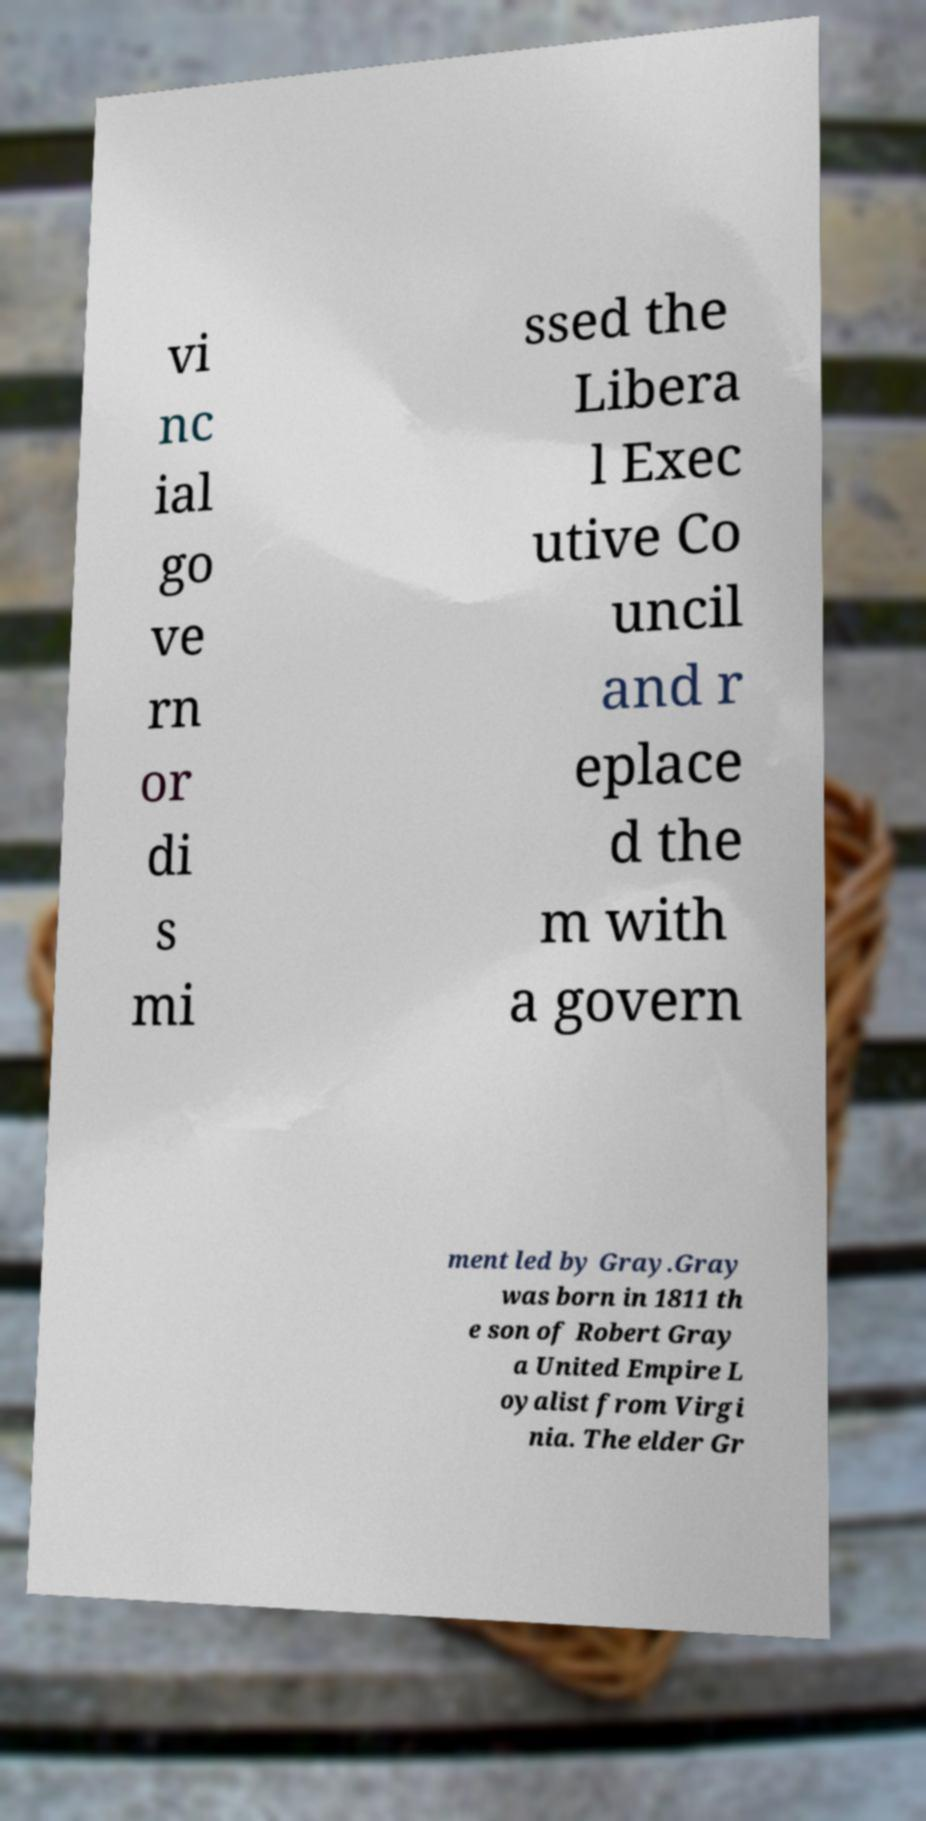Can you accurately transcribe the text from the provided image for me? vi nc ial go ve rn or di s mi ssed the Libera l Exec utive Co uncil and r eplace d the m with a govern ment led by Gray.Gray was born in 1811 th e son of Robert Gray a United Empire L oyalist from Virgi nia. The elder Gr 